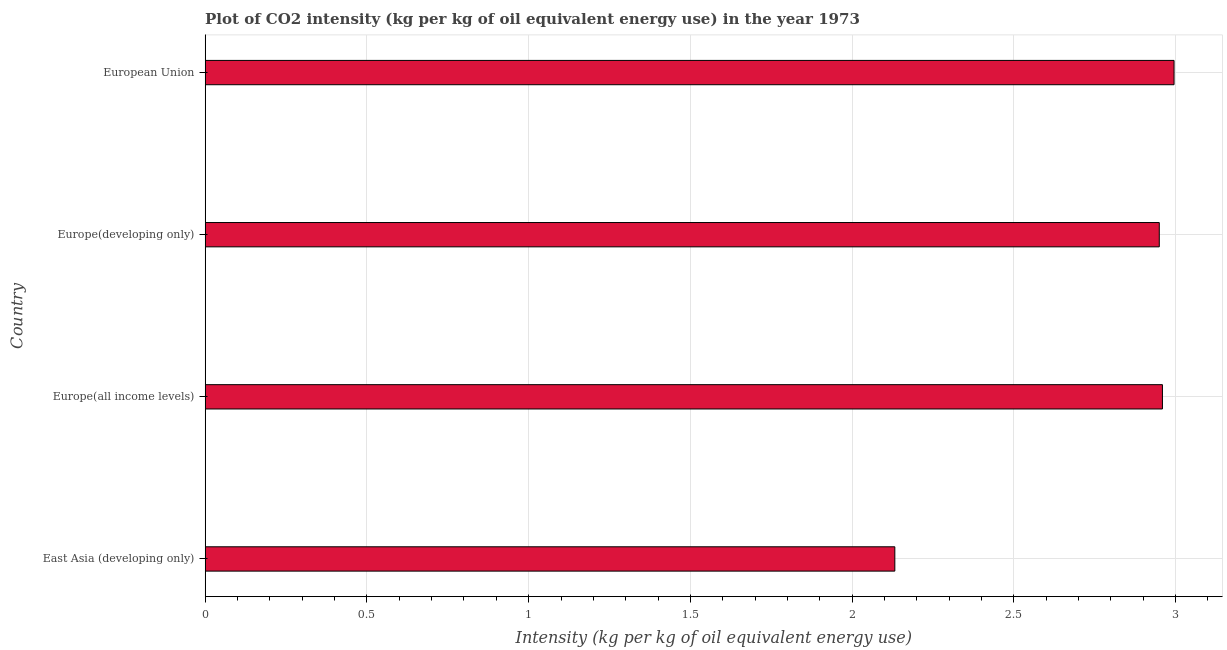Does the graph contain any zero values?
Provide a short and direct response. No. Does the graph contain grids?
Ensure brevity in your answer.  Yes. What is the title of the graph?
Your answer should be compact. Plot of CO2 intensity (kg per kg of oil equivalent energy use) in the year 1973. What is the label or title of the X-axis?
Offer a terse response. Intensity (kg per kg of oil equivalent energy use). What is the label or title of the Y-axis?
Your answer should be compact. Country. What is the co2 intensity in Europe(all income levels)?
Provide a short and direct response. 2.96. Across all countries, what is the maximum co2 intensity?
Provide a short and direct response. 3. Across all countries, what is the minimum co2 intensity?
Your answer should be compact. 2.13. In which country was the co2 intensity maximum?
Your response must be concise. European Union. In which country was the co2 intensity minimum?
Offer a terse response. East Asia (developing only). What is the sum of the co2 intensity?
Provide a succinct answer. 11.04. What is the difference between the co2 intensity in East Asia (developing only) and European Union?
Offer a very short reply. -0.86. What is the average co2 intensity per country?
Make the answer very short. 2.76. What is the median co2 intensity?
Your answer should be compact. 2.95. In how many countries, is the co2 intensity greater than 0.6 kg?
Offer a very short reply. 4. What is the ratio of the co2 intensity in Europe(all income levels) to that in Europe(developing only)?
Offer a terse response. 1. Is the co2 intensity in East Asia (developing only) less than that in Europe(all income levels)?
Ensure brevity in your answer.  Yes. What is the difference between the highest and the second highest co2 intensity?
Give a very brief answer. 0.04. What is the difference between the highest and the lowest co2 intensity?
Offer a very short reply. 0.86. In how many countries, is the co2 intensity greater than the average co2 intensity taken over all countries?
Provide a succinct answer. 3. How many bars are there?
Make the answer very short. 4. Are all the bars in the graph horizontal?
Ensure brevity in your answer.  Yes. Are the values on the major ticks of X-axis written in scientific E-notation?
Keep it short and to the point. No. What is the Intensity (kg per kg of oil equivalent energy use) of East Asia (developing only)?
Make the answer very short. 2.13. What is the Intensity (kg per kg of oil equivalent energy use) in Europe(all income levels)?
Give a very brief answer. 2.96. What is the Intensity (kg per kg of oil equivalent energy use) of Europe(developing only)?
Keep it short and to the point. 2.95. What is the Intensity (kg per kg of oil equivalent energy use) of European Union?
Make the answer very short. 3. What is the difference between the Intensity (kg per kg of oil equivalent energy use) in East Asia (developing only) and Europe(all income levels)?
Your answer should be very brief. -0.83. What is the difference between the Intensity (kg per kg of oil equivalent energy use) in East Asia (developing only) and Europe(developing only)?
Provide a succinct answer. -0.82. What is the difference between the Intensity (kg per kg of oil equivalent energy use) in East Asia (developing only) and European Union?
Offer a very short reply. -0.86. What is the difference between the Intensity (kg per kg of oil equivalent energy use) in Europe(all income levels) and Europe(developing only)?
Give a very brief answer. 0.01. What is the difference between the Intensity (kg per kg of oil equivalent energy use) in Europe(all income levels) and European Union?
Your answer should be compact. -0.04. What is the difference between the Intensity (kg per kg of oil equivalent energy use) in Europe(developing only) and European Union?
Keep it short and to the point. -0.05. What is the ratio of the Intensity (kg per kg of oil equivalent energy use) in East Asia (developing only) to that in Europe(all income levels)?
Provide a succinct answer. 0.72. What is the ratio of the Intensity (kg per kg of oil equivalent energy use) in East Asia (developing only) to that in Europe(developing only)?
Your answer should be compact. 0.72. What is the ratio of the Intensity (kg per kg of oil equivalent energy use) in East Asia (developing only) to that in European Union?
Keep it short and to the point. 0.71. What is the ratio of the Intensity (kg per kg of oil equivalent energy use) in Europe(all income levels) to that in Europe(developing only)?
Your answer should be compact. 1. What is the ratio of the Intensity (kg per kg of oil equivalent energy use) in Europe(developing only) to that in European Union?
Your response must be concise. 0.98. 